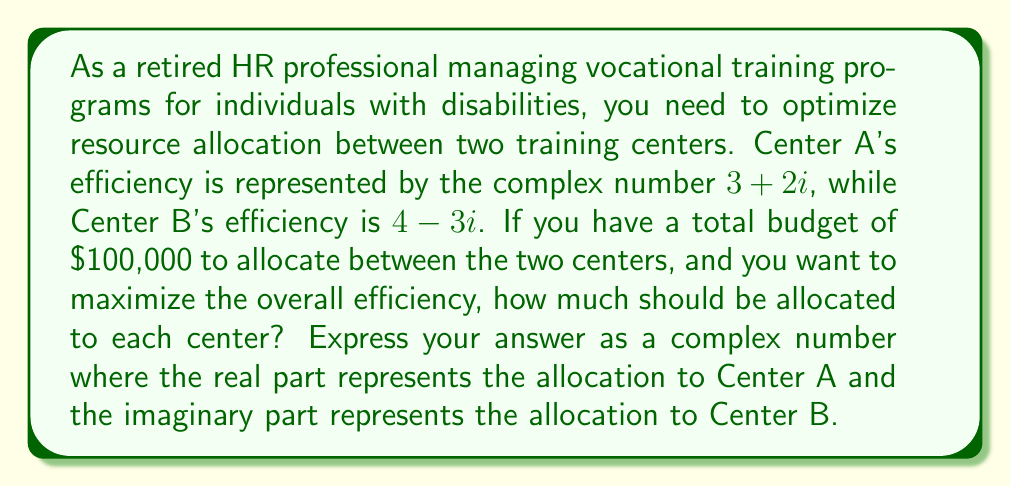Can you solve this math problem? To solve this problem, we need to follow these steps:

1) First, we need to find the magnitude of each center's efficiency. The magnitude of a complex number $a + bi$ is given by $\sqrt{a^2 + b^2}$.

   For Center A: $|3 + 2i| = \sqrt{3^2 + 2^2} = \sqrt{13}$
   For Center B: $|4 - 3i| = \sqrt{4^2 + (-3)^2} = \sqrt{25} = 5$

2) The optimal allocation should be proportional to these magnitudes. Let's call the proportion for Center A as $x$. Then:

   $\frac{x}{\sqrt{13}} = \frac{1-x}{5}$

3) Solving this equation:

   $5x = \sqrt{13}(1-x)$
   $5x = \sqrt{13} - \sqrt{13}x$
   $5x + \sqrt{13}x = \sqrt{13}$
   $x(5 + \sqrt{13}) = \sqrt{13}$
   $x = \frac{\sqrt{13}}{5 + \sqrt{13}}$

4) Now, we can calculate the allocation for Center A:

   $100,000 \cdot \frac{\sqrt{13}}{5 + \sqrt{13}} \approx 41,850.22$

5) The allocation for Center B will be the remaining amount:

   $100,000 - 41,850.22 = 58,149.78$

6) To express this as a complex number, we use the allocation for Center A as the real part and the allocation for Center B as the imaginary part:

   $41,850.22 + 58,149.78i$
Answer: $41,850.22 + 58,149.78i$ 